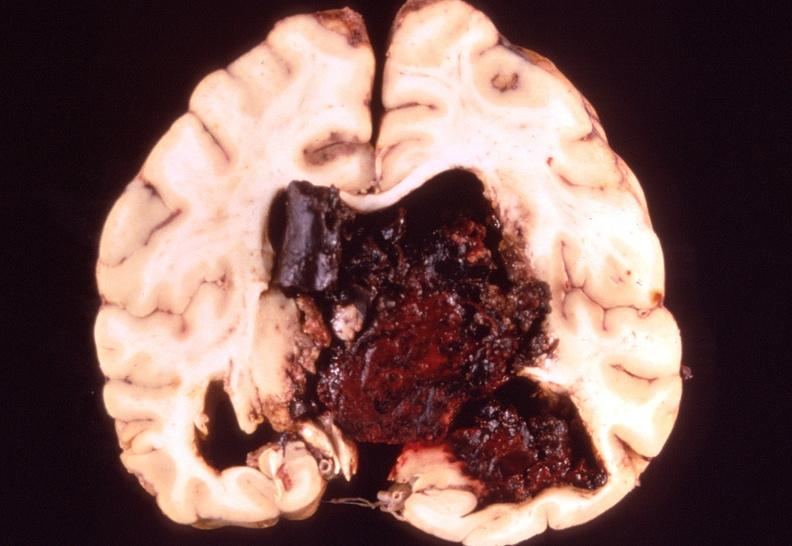does periprostatic vein thrombi show brain, intracerebral hemorrhage?
Answer the question using a single word or phrase. No 